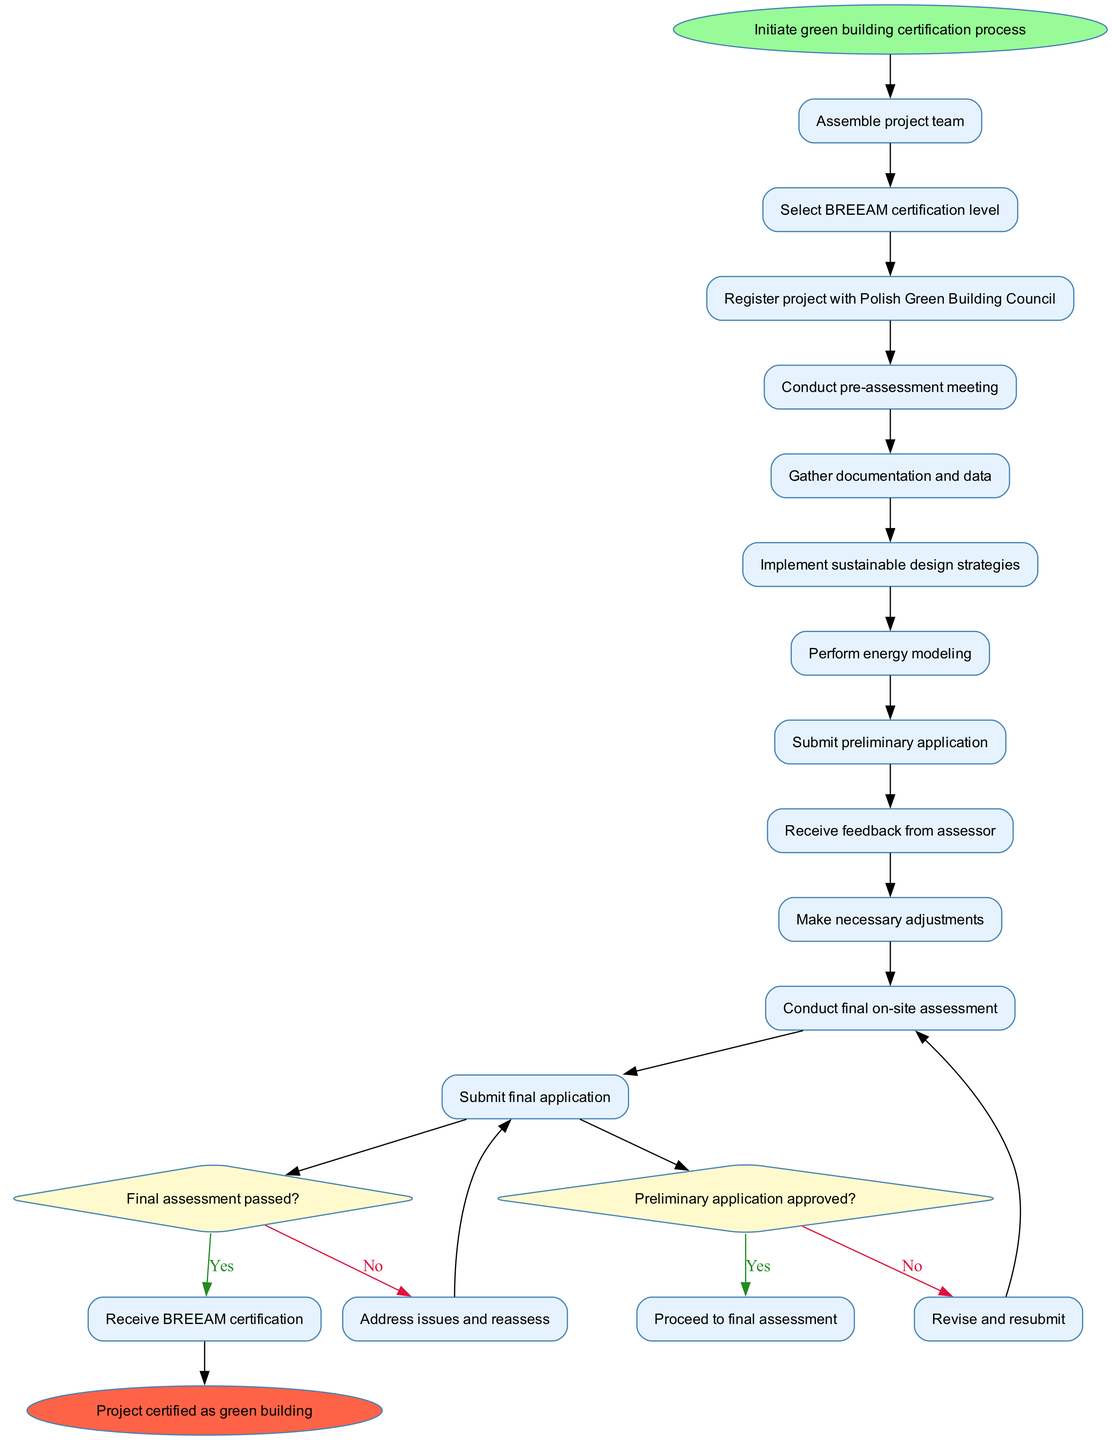What is the first activity in the process? The diagram indicates that the first activity following the initiation of the certification process is "Assemble project team." This can be found directly after the start node.
Answer: Assemble project team How many activities are there in total? Counting the activities listed in the diagram reveals there are 11 activities from "Assemble project team" to "Submit final application."
Answer: 11 What decision follows the submission of the preliminary application? The decision following the submission of the preliminary application is "Preliminary application approved?" This can be identified as branching out from the activity "Submit preliminary application."
Answer: Preliminary application approved? What happens if the preliminary application is not approved? If the preliminary application is not approved, the process flows to "Revise and resubmit," which is connected to the decision diamond node labeled "Preliminary application approved?" with a "No" edge.
Answer: Revise and resubmit What is the last node in the diagram? The last node in this activity diagram is "Project certified as green building," which signifies the successful completion of the certification process following the steps outlined previously.
Answer: Project certified as green building How many edges lead to the final certification node? There are two edges leading to the final certification node; one from the approval of the final assessment (yes edge) and the potential adjustments after addressing any issues (from the no edge of the final assessment decision).
Answer: 2 What occurs after the final assessment if it is passed? If the final assessment is passed, the next step is receiving the "BREEAM certification," which follows directly from the yes edge of the decision "Final assessment passed?" at the end of the process.
Answer: Receive BREEAM certification What is the role of the Polish Green Building Council in the process? The Polish Green Building Council’s role comes into play when the project is registered, shown as one of the key activities in the certification process.
Answer: Register project with Polish Green Building Council What activity is performed after conducting the pre-assessment meeting? After conducting the pre-assessment meeting, the process moves to "Gather documentation and data," which is the next sequential activity following the meeting in the diagram.
Answer: Gather documentation and data 